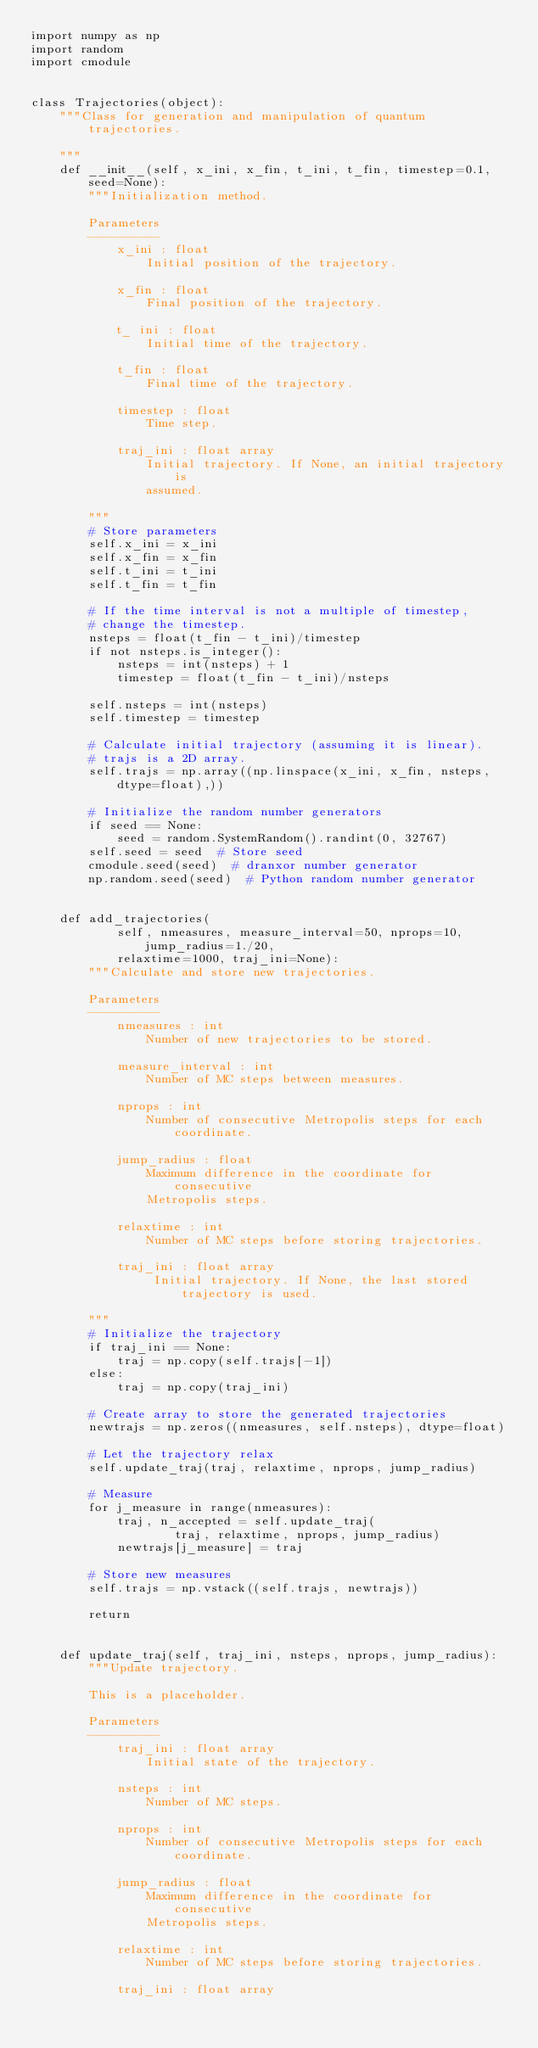<code> <loc_0><loc_0><loc_500><loc_500><_Python_>import numpy as np
import random
import cmodule


class Trajectories(object):
    """Class for generation and manipulation of quantum trajectories.

    """
    def __init__(self, x_ini, x_fin, t_ini, t_fin, timestep=0.1, seed=None):
        """Initialization method.
        
        Parameters
        ----------
            x_ini : float
                Initial position of the trajectory.

            x_fin : float
                Final position of the trajectory.

            t_ ini : float
                Initial time of the trajectory. 

            t_fin : float
                Final time of the trajectory.

            timestep : float
                Time step.

            traj_ini : float array
                Initial trajectory. If None, an initial trajectory is
                assumed.

        """
        # Store parameters
        self.x_ini = x_ini
        self.x_fin = x_fin
        self.t_ini = t_ini
        self.t_fin = t_fin

        # If the time interval is not a multiple of timestep, 
        # change the timestep.
        nsteps = float(t_fin - t_ini)/timestep
        if not nsteps.is_integer():
            nsteps = int(nsteps) + 1
            timestep = float(t_fin - t_ini)/nsteps

        self.nsteps = int(nsteps)
        self.timestep = timestep

        # Calculate initial trajectory (assuming it is linear).
        # trajs is a 2D array.
        self.trajs = np.array((np.linspace(x_ini, x_fin, nsteps, dtype=float),))
        
        # Initialize the random number generators
        if seed == None:
            seed = random.SystemRandom().randint(0, 32767)
        self.seed = seed  # Store seed
        cmodule.seed(seed)  # dranxor number generator
        np.random.seed(seed)  # Python random number generator


    def add_trajectories(
            self, nmeasures, measure_interval=50, nprops=10, jump_radius=1./20,
            relaxtime=1000, traj_ini=None):
        """Calculate and store new trajectories.
            
        Parameters
        ----------
            nmeasures : int
                Number of new trajectories to be stored.

            measure_interval : int
                Number of MC steps between measures.

            nprops : int
                Number of consecutive Metropolis steps for each coordinate.

            jump_radius : float
                Maximum difference in the coordinate for consecutive 
                Metropolis steps.

            relaxtime : int
                Number of MC steps before storing trajectories.

            traj_ini : float array
                 Initial trajectory. If None, the last stored trajectory is used.

        """
        # Initialize the trajectory
        if traj_ini == None:
            traj = np.copy(self.trajs[-1])
        else:
            traj = np.copy(traj_ini)

        # Create array to store the generated trajectories
        newtrajs = np.zeros((nmeasures, self.nsteps), dtype=float)

        # Let the trajectory relax
        self.update_traj(traj, relaxtime, nprops, jump_radius)

        # Measure
        for j_measure in range(nmeasures):
            traj, n_accepted = self.update_traj(
                    traj, relaxtime, nprops, jump_radius)
            newtrajs[j_measure] = traj

        # Store new measures
        self.trajs = np.vstack((self.trajs, newtrajs))

        return


    def update_traj(self, traj_ini, nsteps, nprops, jump_radius):
        """Update trajectory.

        This is a placeholder.

        Parameters
        ----------
            traj_ini : float array
                Initial state of the trajectory.

            nsteps : int
                Number of MC steps.

            nprops : int
                Number of consecutive Metropolis steps for each coordinate.

            jump_radius : float
                Maximum difference in the coordinate for consecutive 
                Metropolis steps.

            relaxtime : int
                Number of MC steps before storing trajectories.

            traj_ini : float array</code> 